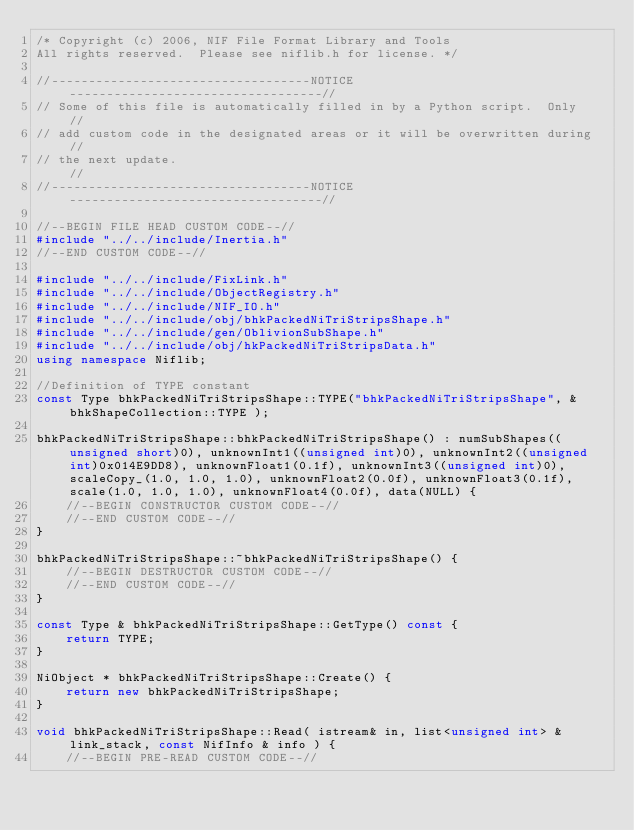<code> <loc_0><loc_0><loc_500><loc_500><_C++_>/* Copyright (c) 2006, NIF File Format Library and Tools
All rights reserved.  Please see niflib.h for license. */

//-----------------------------------NOTICE----------------------------------//
// Some of this file is automatically filled in by a Python script.  Only    //
// add custom code in the designated areas or it will be overwritten during  //
// the next update.                                                          //
//-----------------------------------NOTICE----------------------------------//

//--BEGIN FILE HEAD CUSTOM CODE--//
#include "../../include/Inertia.h"
//--END CUSTOM CODE--//

#include "../../include/FixLink.h"
#include "../../include/ObjectRegistry.h"
#include "../../include/NIF_IO.h"
#include "../../include/obj/bhkPackedNiTriStripsShape.h"
#include "../../include/gen/OblivionSubShape.h"
#include "../../include/obj/hkPackedNiTriStripsData.h"
using namespace Niflib;

//Definition of TYPE constant
const Type bhkPackedNiTriStripsShape::TYPE("bhkPackedNiTriStripsShape", &bhkShapeCollection::TYPE );

bhkPackedNiTriStripsShape::bhkPackedNiTriStripsShape() : numSubShapes((unsigned short)0), unknownInt1((unsigned int)0), unknownInt2((unsigned int)0x014E9DD8), unknownFloat1(0.1f), unknownInt3((unsigned int)0), scaleCopy_(1.0, 1.0, 1.0), unknownFloat2(0.0f), unknownFloat3(0.1f), scale(1.0, 1.0, 1.0), unknownFloat4(0.0f), data(NULL) {
	//--BEGIN CONSTRUCTOR CUSTOM CODE--//
	//--END CUSTOM CODE--//
}

bhkPackedNiTriStripsShape::~bhkPackedNiTriStripsShape() {
	//--BEGIN DESTRUCTOR CUSTOM CODE--//
	//--END CUSTOM CODE--//
}

const Type & bhkPackedNiTriStripsShape::GetType() const {
	return TYPE;
}

NiObject * bhkPackedNiTriStripsShape::Create() {
	return new bhkPackedNiTriStripsShape;
}

void bhkPackedNiTriStripsShape::Read( istream& in, list<unsigned int> & link_stack, const NifInfo & info ) {
	//--BEGIN PRE-READ CUSTOM CODE--//</code> 